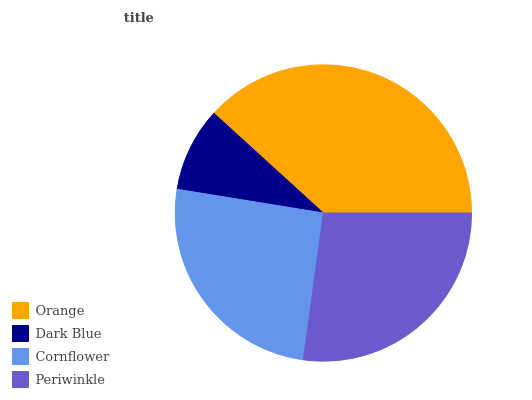Is Dark Blue the minimum?
Answer yes or no. Yes. Is Orange the maximum?
Answer yes or no. Yes. Is Cornflower the minimum?
Answer yes or no. No. Is Cornflower the maximum?
Answer yes or no. No. Is Cornflower greater than Dark Blue?
Answer yes or no. Yes. Is Dark Blue less than Cornflower?
Answer yes or no. Yes. Is Dark Blue greater than Cornflower?
Answer yes or no. No. Is Cornflower less than Dark Blue?
Answer yes or no. No. Is Periwinkle the high median?
Answer yes or no. Yes. Is Cornflower the low median?
Answer yes or no. Yes. Is Dark Blue the high median?
Answer yes or no. No. Is Orange the low median?
Answer yes or no. No. 